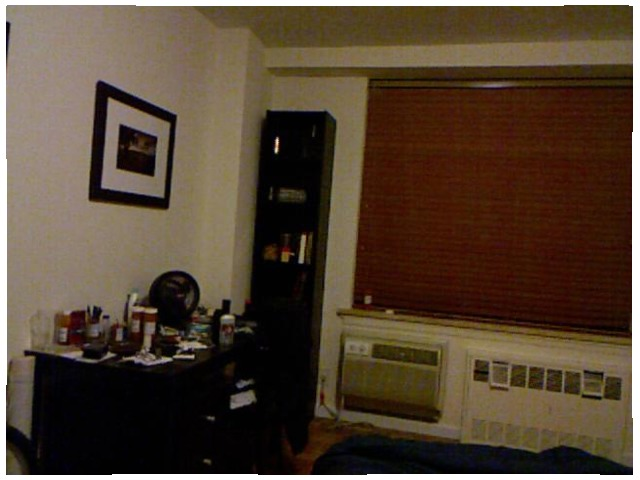<image>
Is there a air conditioner under the window? Yes. The air conditioner is positioned underneath the window, with the window above it in the vertical space. 